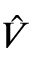<formula> <loc_0><loc_0><loc_500><loc_500>\hat { V }</formula> 